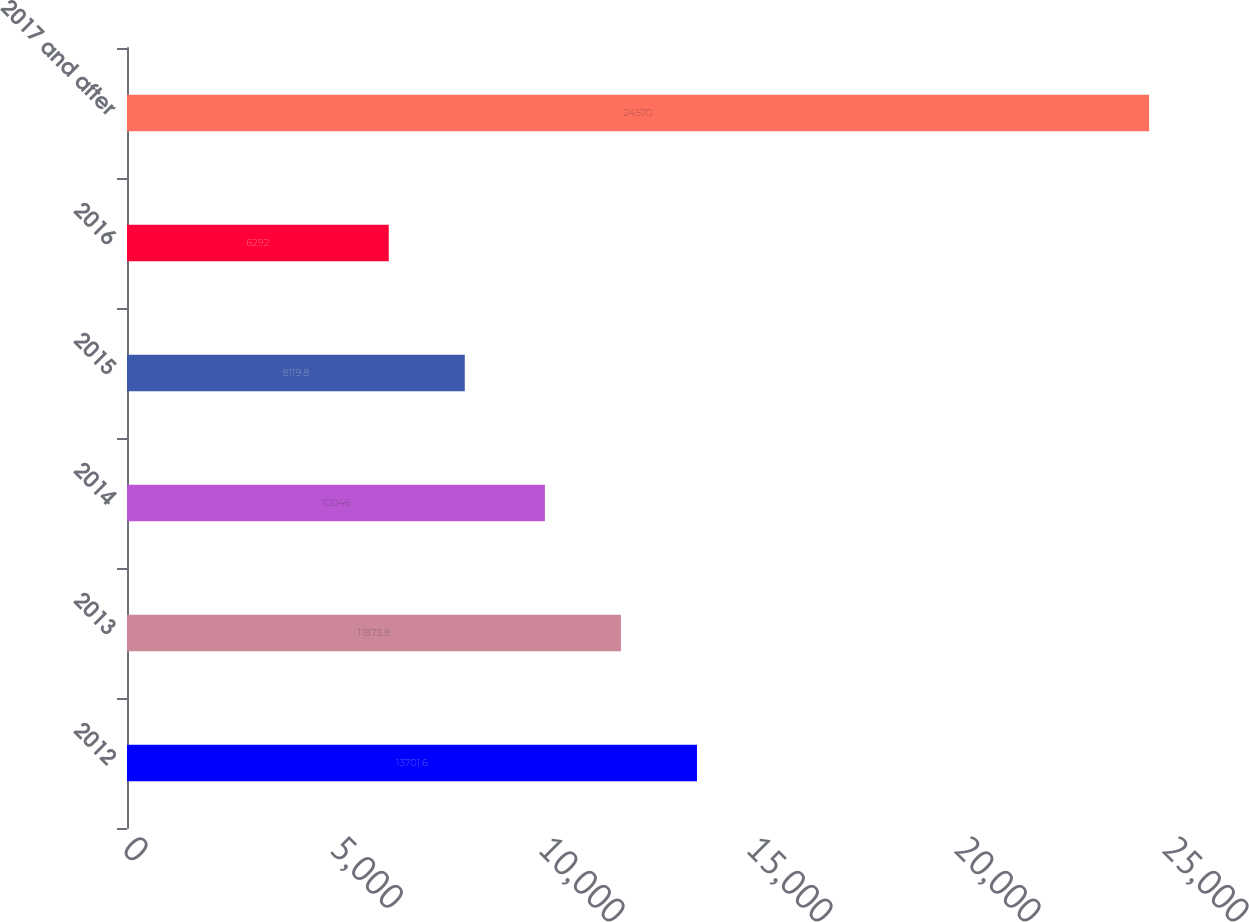Convert chart to OTSL. <chart><loc_0><loc_0><loc_500><loc_500><bar_chart><fcel>2012<fcel>2013<fcel>2014<fcel>2015<fcel>2016<fcel>2017 and after<nl><fcel>13701.6<fcel>11873.8<fcel>10046<fcel>8119.8<fcel>6292<fcel>24570<nl></chart> 